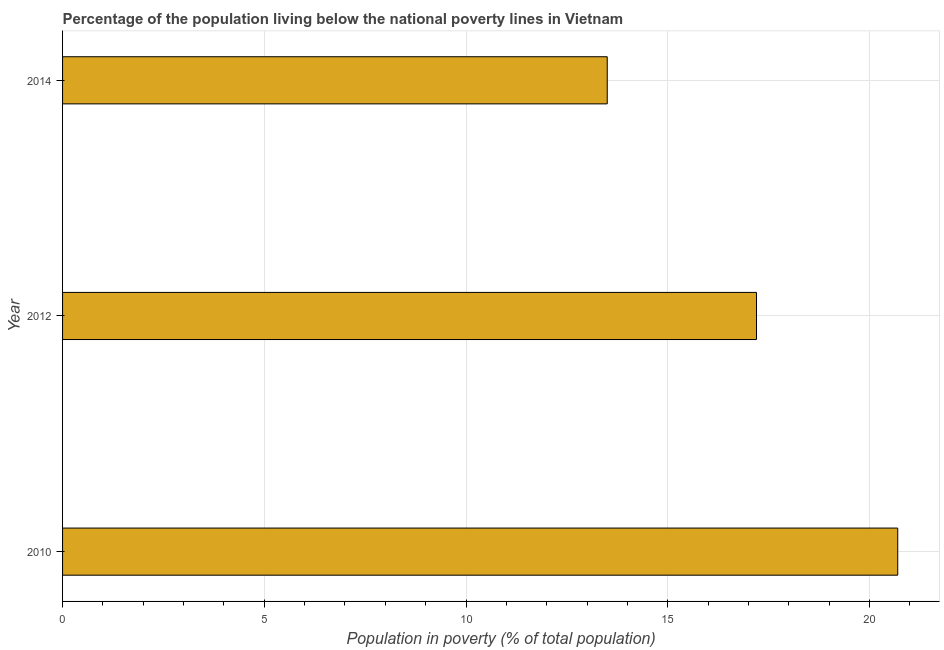Does the graph contain any zero values?
Offer a very short reply. No. What is the title of the graph?
Ensure brevity in your answer.  Percentage of the population living below the national poverty lines in Vietnam. What is the label or title of the X-axis?
Offer a very short reply. Population in poverty (% of total population). Across all years, what is the maximum percentage of population living below poverty line?
Offer a very short reply. 20.7. Across all years, what is the minimum percentage of population living below poverty line?
Offer a terse response. 13.5. In which year was the percentage of population living below poverty line minimum?
Provide a short and direct response. 2014. What is the sum of the percentage of population living below poverty line?
Your response must be concise. 51.4. What is the average percentage of population living below poverty line per year?
Ensure brevity in your answer.  17.13. In how many years, is the percentage of population living below poverty line greater than 7 %?
Provide a short and direct response. 3. Do a majority of the years between 2010 and 2012 (inclusive) have percentage of population living below poverty line greater than 4 %?
Offer a very short reply. Yes. What is the ratio of the percentage of population living below poverty line in 2012 to that in 2014?
Keep it short and to the point. 1.27. Is the difference between the percentage of population living below poverty line in 2012 and 2014 greater than the difference between any two years?
Offer a terse response. No. What is the difference between the highest and the second highest percentage of population living below poverty line?
Provide a short and direct response. 3.5. Is the sum of the percentage of population living below poverty line in 2010 and 2012 greater than the maximum percentage of population living below poverty line across all years?
Keep it short and to the point. Yes. Are all the bars in the graph horizontal?
Offer a very short reply. Yes. How many years are there in the graph?
Keep it short and to the point. 3. Are the values on the major ticks of X-axis written in scientific E-notation?
Make the answer very short. No. What is the Population in poverty (% of total population) in 2010?
Offer a terse response. 20.7. What is the ratio of the Population in poverty (% of total population) in 2010 to that in 2012?
Offer a very short reply. 1.2. What is the ratio of the Population in poverty (% of total population) in 2010 to that in 2014?
Provide a short and direct response. 1.53. What is the ratio of the Population in poverty (% of total population) in 2012 to that in 2014?
Provide a short and direct response. 1.27. 